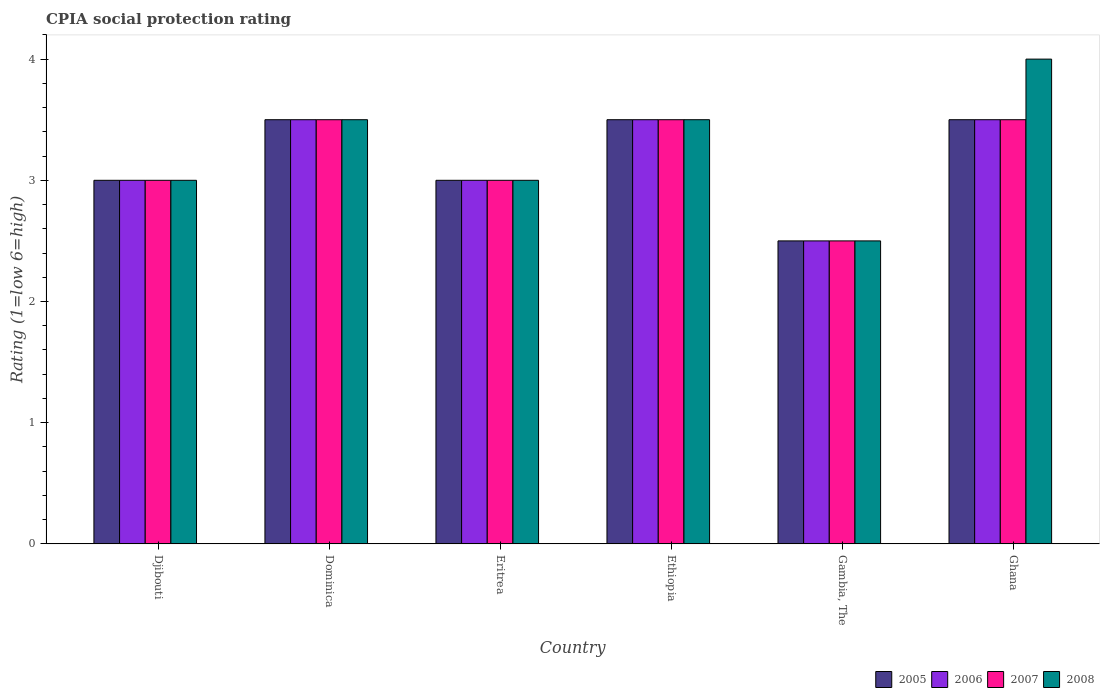How many different coloured bars are there?
Your response must be concise. 4. Are the number of bars per tick equal to the number of legend labels?
Offer a terse response. Yes. What is the label of the 3rd group of bars from the left?
Keep it short and to the point. Eritrea. In how many cases, is the number of bars for a given country not equal to the number of legend labels?
Your answer should be very brief. 0. What is the CPIA rating in 2008 in Eritrea?
Provide a succinct answer. 3. Across all countries, what is the maximum CPIA rating in 2007?
Your answer should be very brief. 3.5. Across all countries, what is the minimum CPIA rating in 2006?
Your answer should be very brief. 2.5. In which country was the CPIA rating in 2008 maximum?
Your answer should be very brief. Ghana. In which country was the CPIA rating in 2006 minimum?
Provide a short and direct response. Gambia, The. What is the total CPIA rating in 2007 in the graph?
Ensure brevity in your answer.  19. What is the difference between the CPIA rating in 2006 in Eritrea and that in Ghana?
Offer a terse response. -0.5. What is the difference between the CPIA rating in 2007 in Eritrea and the CPIA rating in 2005 in Ethiopia?
Ensure brevity in your answer.  -0.5. What is the average CPIA rating in 2006 per country?
Give a very brief answer. 3.17. What is the difference between the CPIA rating of/in 2008 and CPIA rating of/in 2007 in Gambia, The?
Your answer should be compact. 0. In how many countries, is the CPIA rating in 2007 greater than 1.2?
Make the answer very short. 6. What is the ratio of the CPIA rating in 2005 in Ethiopia to that in Gambia, The?
Your answer should be very brief. 1.4. In how many countries, is the CPIA rating in 2008 greater than the average CPIA rating in 2008 taken over all countries?
Your answer should be compact. 3. What does the 2nd bar from the right in Gambia, The represents?
Keep it short and to the point. 2007. Is it the case that in every country, the sum of the CPIA rating in 2006 and CPIA rating in 2007 is greater than the CPIA rating in 2005?
Your answer should be compact. Yes. Are all the bars in the graph horizontal?
Provide a succinct answer. No. How many countries are there in the graph?
Make the answer very short. 6. What is the difference between two consecutive major ticks on the Y-axis?
Your answer should be very brief. 1. Are the values on the major ticks of Y-axis written in scientific E-notation?
Keep it short and to the point. No. Does the graph contain any zero values?
Keep it short and to the point. No. Does the graph contain grids?
Make the answer very short. No. What is the title of the graph?
Make the answer very short. CPIA social protection rating. What is the label or title of the X-axis?
Your answer should be compact. Country. What is the Rating (1=low 6=high) in 2005 in Djibouti?
Offer a terse response. 3. What is the Rating (1=low 6=high) in 2006 in Djibouti?
Your answer should be very brief. 3. What is the Rating (1=low 6=high) in 2007 in Dominica?
Offer a terse response. 3.5. What is the Rating (1=low 6=high) in 2008 in Dominica?
Your answer should be compact. 3.5. What is the Rating (1=low 6=high) of 2005 in Eritrea?
Provide a succinct answer. 3. What is the Rating (1=low 6=high) of 2008 in Eritrea?
Give a very brief answer. 3. What is the Rating (1=low 6=high) of 2006 in Ethiopia?
Offer a very short reply. 3.5. What is the Rating (1=low 6=high) of 2006 in Gambia, The?
Your answer should be compact. 2.5. What is the Rating (1=low 6=high) in 2005 in Ghana?
Your answer should be very brief. 3.5. What is the Rating (1=low 6=high) in 2006 in Ghana?
Offer a very short reply. 3.5. What is the Rating (1=low 6=high) of 2007 in Ghana?
Ensure brevity in your answer.  3.5. Across all countries, what is the maximum Rating (1=low 6=high) in 2005?
Give a very brief answer. 3.5. Across all countries, what is the maximum Rating (1=low 6=high) of 2008?
Your answer should be compact. 4. Across all countries, what is the minimum Rating (1=low 6=high) of 2008?
Offer a very short reply. 2.5. What is the total Rating (1=low 6=high) in 2005 in the graph?
Offer a very short reply. 19. What is the total Rating (1=low 6=high) of 2008 in the graph?
Make the answer very short. 19.5. What is the difference between the Rating (1=low 6=high) in 2006 in Djibouti and that in Dominica?
Offer a very short reply. -0.5. What is the difference between the Rating (1=low 6=high) of 2007 in Djibouti and that in Dominica?
Offer a very short reply. -0.5. What is the difference between the Rating (1=low 6=high) of 2008 in Djibouti and that in Dominica?
Offer a very short reply. -0.5. What is the difference between the Rating (1=low 6=high) in 2006 in Djibouti and that in Eritrea?
Provide a short and direct response. 0. What is the difference between the Rating (1=low 6=high) of 2008 in Djibouti and that in Eritrea?
Offer a very short reply. 0. What is the difference between the Rating (1=low 6=high) in 2005 in Djibouti and that in Ethiopia?
Make the answer very short. -0.5. What is the difference between the Rating (1=low 6=high) of 2006 in Djibouti and that in Ethiopia?
Offer a very short reply. -0.5. What is the difference between the Rating (1=low 6=high) in 2005 in Djibouti and that in Gambia, The?
Your response must be concise. 0.5. What is the difference between the Rating (1=low 6=high) of 2006 in Djibouti and that in Gambia, The?
Your response must be concise. 0.5. What is the difference between the Rating (1=low 6=high) in 2008 in Djibouti and that in Gambia, The?
Ensure brevity in your answer.  0.5. What is the difference between the Rating (1=low 6=high) of 2005 in Djibouti and that in Ghana?
Your answer should be very brief. -0.5. What is the difference between the Rating (1=low 6=high) of 2008 in Djibouti and that in Ghana?
Offer a terse response. -1. What is the difference between the Rating (1=low 6=high) of 2006 in Dominica and that in Eritrea?
Offer a very short reply. 0.5. What is the difference between the Rating (1=low 6=high) in 2008 in Dominica and that in Eritrea?
Ensure brevity in your answer.  0.5. What is the difference between the Rating (1=low 6=high) of 2005 in Dominica and that in Ethiopia?
Provide a succinct answer. 0. What is the difference between the Rating (1=low 6=high) of 2007 in Dominica and that in Ethiopia?
Keep it short and to the point. 0. What is the difference between the Rating (1=low 6=high) in 2008 in Dominica and that in Ethiopia?
Offer a terse response. 0. What is the difference between the Rating (1=low 6=high) of 2005 in Dominica and that in Gambia, The?
Your answer should be very brief. 1. What is the difference between the Rating (1=low 6=high) in 2007 in Dominica and that in Gambia, The?
Offer a very short reply. 1. What is the difference between the Rating (1=low 6=high) in 2008 in Dominica and that in Gambia, The?
Make the answer very short. 1. What is the difference between the Rating (1=low 6=high) in 2006 in Dominica and that in Ghana?
Make the answer very short. 0. What is the difference between the Rating (1=low 6=high) in 2007 in Eritrea and that in Ethiopia?
Offer a terse response. -0.5. What is the difference between the Rating (1=low 6=high) in 2005 in Eritrea and that in Gambia, The?
Your answer should be very brief. 0.5. What is the difference between the Rating (1=low 6=high) of 2006 in Eritrea and that in Gambia, The?
Offer a very short reply. 0.5. What is the difference between the Rating (1=low 6=high) of 2008 in Eritrea and that in Gambia, The?
Your answer should be compact. 0.5. What is the difference between the Rating (1=low 6=high) in 2005 in Eritrea and that in Ghana?
Ensure brevity in your answer.  -0.5. What is the difference between the Rating (1=low 6=high) in 2008 in Eritrea and that in Ghana?
Your answer should be very brief. -1. What is the difference between the Rating (1=low 6=high) of 2006 in Ethiopia and that in Gambia, The?
Offer a terse response. 1. What is the difference between the Rating (1=low 6=high) of 2008 in Ethiopia and that in Gambia, The?
Offer a terse response. 1. What is the difference between the Rating (1=low 6=high) of 2008 in Ethiopia and that in Ghana?
Offer a terse response. -0.5. What is the difference between the Rating (1=low 6=high) in 2005 in Gambia, The and that in Ghana?
Provide a short and direct response. -1. What is the difference between the Rating (1=low 6=high) in 2006 in Gambia, The and that in Ghana?
Your response must be concise. -1. What is the difference between the Rating (1=low 6=high) in 2007 in Gambia, The and that in Ghana?
Ensure brevity in your answer.  -1. What is the difference between the Rating (1=low 6=high) in 2005 in Djibouti and the Rating (1=low 6=high) in 2006 in Dominica?
Keep it short and to the point. -0.5. What is the difference between the Rating (1=low 6=high) of 2005 in Djibouti and the Rating (1=low 6=high) of 2008 in Dominica?
Give a very brief answer. -0.5. What is the difference between the Rating (1=low 6=high) in 2007 in Djibouti and the Rating (1=low 6=high) in 2008 in Dominica?
Your answer should be compact. -0.5. What is the difference between the Rating (1=low 6=high) in 2006 in Djibouti and the Rating (1=low 6=high) in 2008 in Eritrea?
Your answer should be very brief. 0. What is the difference between the Rating (1=low 6=high) in 2005 in Djibouti and the Rating (1=low 6=high) in 2006 in Ethiopia?
Offer a very short reply. -0.5. What is the difference between the Rating (1=low 6=high) of 2005 in Djibouti and the Rating (1=low 6=high) of 2007 in Ethiopia?
Make the answer very short. -0.5. What is the difference between the Rating (1=low 6=high) in 2006 in Djibouti and the Rating (1=low 6=high) in 2008 in Ethiopia?
Your answer should be very brief. -0.5. What is the difference between the Rating (1=low 6=high) in 2006 in Djibouti and the Rating (1=low 6=high) in 2007 in Gambia, The?
Make the answer very short. 0.5. What is the difference between the Rating (1=low 6=high) of 2007 in Djibouti and the Rating (1=low 6=high) of 2008 in Gambia, The?
Ensure brevity in your answer.  0.5. What is the difference between the Rating (1=low 6=high) of 2005 in Djibouti and the Rating (1=low 6=high) of 2007 in Ghana?
Ensure brevity in your answer.  -0.5. What is the difference between the Rating (1=low 6=high) in 2006 in Djibouti and the Rating (1=low 6=high) in 2008 in Ghana?
Provide a succinct answer. -1. What is the difference between the Rating (1=low 6=high) of 2005 in Dominica and the Rating (1=low 6=high) of 2006 in Eritrea?
Your answer should be compact. 0.5. What is the difference between the Rating (1=low 6=high) in 2007 in Dominica and the Rating (1=low 6=high) in 2008 in Eritrea?
Your answer should be very brief. 0.5. What is the difference between the Rating (1=low 6=high) in 2006 in Dominica and the Rating (1=low 6=high) in 2007 in Gambia, The?
Offer a very short reply. 1. What is the difference between the Rating (1=low 6=high) of 2006 in Dominica and the Rating (1=low 6=high) of 2008 in Gambia, The?
Your answer should be very brief. 1. What is the difference between the Rating (1=low 6=high) of 2007 in Dominica and the Rating (1=low 6=high) of 2008 in Gambia, The?
Keep it short and to the point. 1. What is the difference between the Rating (1=low 6=high) of 2005 in Dominica and the Rating (1=low 6=high) of 2006 in Ghana?
Offer a terse response. 0. What is the difference between the Rating (1=low 6=high) in 2005 in Dominica and the Rating (1=low 6=high) in 2007 in Ghana?
Offer a very short reply. 0. What is the difference between the Rating (1=low 6=high) of 2005 in Dominica and the Rating (1=low 6=high) of 2008 in Ghana?
Provide a short and direct response. -0.5. What is the difference between the Rating (1=low 6=high) of 2006 in Dominica and the Rating (1=low 6=high) of 2007 in Ghana?
Your answer should be very brief. 0. What is the difference between the Rating (1=low 6=high) in 2005 in Eritrea and the Rating (1=low 6=high) in 2008 in Ethiopia?
Give a very brief answer. -0.5. What is the difference between the Rating (1=low 6=high) in 2005 in Eritrea and the Rating (1=low 6=high) in 2007 in Gambia, The?
Your response must be concise. 0.5. What is the difference between the Rating (1=low 6=high) in 2005 in Eritrea and the Rating (1=low 6=high) in 2008 in Gambia, The?
Ensure brevity in your answer.  0.5. What is the difference between the Rating (1=low 6=high) in 2006 in Eritrea and the Rating (1=low 6=high) in 2008 in Gambia, The?
Offer a terse response. 0.5. What is the difference between the Rating (1=low 6=high) in 2007 in Eritrea and the Rating (1=low 6=high) in 2008 in Gambia, The?
Ensure brevity in your answer.  0.5. What is the difference between the Rating (1=low 6=high) of 2006 in Eritrea and the Rating (1=low 6=high) of 2007 in Ghana?
Your answer should be very brief. -0.5. What is the difference between the Rating (1=low 6=high) in 2006 in Eritrea and the Rating (1=low 6=high) in 2008 in Ghana?
Offer a very short reply. -1. What is the difference between the Rating (1=low 6=high) in 2005 in Ethiopia and the Rating (1=low 6=high) in 2006 in Gambia, The?
Your answer should be very brief. 1. What is the difference between the Rating (1=low 6=high) of 2005 in Ethiopia and the Rating (1=low 6=high) of 2007 in Gambia, The?
Provide a succinct answer. 1. What is the difference between the Rating (1=low 6=high) in 2005 in Ethiopia and the Rating (1=low 6=high) in 2008 in Gambia, The?
Keep it short and to the point. 1. What is the difference between the Rating (1=low 6=high) of 2006 in Ethiopia and the Rating (1=low 6=high) of 2007 in Gambia, The?
Offer a very short reply. 1. What is the difference between the Rating (1=low 6=high) in 2006 in Ethiopia and the Rating (1=low 6=high) in 2008 in Gambia, The?
Ensure brevity in your answer.  1. What is the difference between the Rating (1=low 6=high) in 2007 in Ethiopia and the Rating (1=low 6=high) in 2008 in Gambia, The?
Give a very brief answer. 1. What is the difference between the Rating (1=low 6=high) of 2005 in Ethiopia and the Rating (1=low 6=high) of 2006 in Ghana?
Give a very brief answer. 0. What is the difference between the Rating (1=low 6=high) of 2006 in Ethiopia and the Rating (1=low 6=high) of 2008 in Ghana?
Make the answer very short. -0.5. What is the difference between the Rating (1=low 6=high) of 2007 in Ethiopia and the Rating (1=low 6=high) of 2008 in Ghana?
Your response must be concise. -0.5. What is the difference between the Rating (1=low 6=high) of 2005 in Gambia, The and the Rating (1=low 6=high) of 2007 in Ghana?
Provide a short and direct response. -1. What is the difference between the Rating (1=low 6=high) in 2005 in Gambia, The and the Rating (1=low 6=high) in 2008 in Ghana?
Keep it short and to the point. -1.5. What is the difference between the Rating (1=low 6=high) of 2006 in Gambia, The and the Rating (1=low 6=high) of 2007 in Ghana?
Keep it short and to the point. -1. What is the difference between the Rating (1=low 6=high) in 2006 in Gambia, The and the Rating (1=low 6=high) in 2008 in Ghana?
Provide a succinct answer. -1.5. What is the average Rating (1=low 6=high) in 2005 per country?
Offer a very short reply. 3.17. What is the average Rating (1=low 6=high) of 2006 per country?
Offer a terse response. 3.17. What is the average Rating (1=low 6=high) of 2007 per country?
Provide a succinct answer. 3.17. What is the average Rating (1=low 6=high) in 2008 per country?
Make the answer very short. 3.25. What is the difference between the Rating (1=low 6=high) in 2005 and Rating (1=low 6=high) in 2007 in Djibouti?
Make the answer very short. 0. What is the difference between the Rating (1=low 6=high) in 2006 and Rating (1=low 6=high) in 2008 in Djibouti?
Ensure brevity in your answer.  0. What is the difference between the Rating (1=low 6=high) of 2007 and Rating (1=low 6=high) of 2008 in Djibouti?
Offer a very short reply. 0. What is the difference between the Rating (1=low 6=high) in 2005 and Rating (1=low 6=high) in 2007 in Dominica?
Provide a short and direct response. 0. What is the difference between the Rating (1=low 6=high) in 2005 and Rating (1=low 6=high) in 2008 in Dominica?
Keep it short and to the point. 0. What is the difference between the Rating (1=low 6=high) of 2006 and Rating (1=low 6=high) of 2007 in Dominica?
Provide a short and direct response. 0. What is the difference between the Rating (1=low 6=high) in 2006 and Rating (1=low 6=high) in 2008 in Dominica?
Your response must be concise. 0. What is the difference between the Rating (1=low 6=high) of 2005 and Rating (1=low 6=high) of 2007 in Eritrea?
Provide a short and direct response. 0. What is the difference between the Rating (1=low 6=high) of 2005 and Rating (1=low 6=high) of 2008 in Eritrea?
Your answer should be very brief. 0. What is the difference between the Rating (1=low 6=high) of 2006 and Rating (1=low 6=high) of 2007 in Eritrea?
Give a very brief answer. 0. What is the difference between the Rating (1=low 6=high) in 2005 and Rating (1=low 6=high) in 2007 in Ethiopia?
Give a very brief answer. 0. What is the difference between the Rating (1=low 6=high) in 2007 and Rating (1=low 6=high) in 2008 in Ethiopia?
Your response must be concise. 0. What is the difference between the Rating (1=low 6=high) in 2005 and Rating (1=low 6=high) in 2007 in Gambia, The?
Your answer should be compact. 0. What is the difference between the Rating (1=low 6=high) of 2005 and Rating (1=low 6=high) of 2008 in Gambia, The?
Your response must be concise. 0. What is the difference between the Rating (1=low 6=high) of 2006 and Rating (1=low 6=high) of 2007 in Gambia, The?
Give a very brief answer. 0. What is the difference between the Rating (1=low 6=high) of 2006 and Rating (1=low 6=high) of 2008 in Gambia, The?
Make the answer very short. 0. What is the difference between the Rating (1=low 6=high) in 2007 and Rating (1=low 6=high) in 2008 in Gambia, The?
Make the answer very short. 0. What is the difference between the Rating (1=low 6=high) in 2005 and Rating (1=low 6=high) in 2007 in Ghana?
Provide a short and direct response. 0. What is the difference between the Rating (1=low 6=high) of 2005 and Rating (1=low 6=high) of 2008 in Ghana?
Ensure brevity in your answer.  -0.5. What is the difference between the Rating (1=low 6=high) in 2007 and Rating (1=low 6=high) in 2008 in Ghana?
Your response must be concise. -0.5. What is the ratio of the Rating (1=low 6=high) of 2005 in Djibouti to that in Eritrea?
Provide a short and direct response. 1. What is the ratio of the Rating (1=low 6=high) of 2006 in Djibouti to that in Eritrea?
Your answer should be compact. 1. What is the ratio of the Rating (1=low 6=high) of 2008 in Djibouti to that in Eritrea?
Make the answer very short. 1. What is the ratio of the Rating (1=low 6=high) of 2005 in Djibouti to that in Ethiopia?
Your answer should be compact. 0.86. What is the ratio of the Rating (1=low 6=high) in 2007 in Djibouti to that in Ethiopia?
Your answer should be compact. 0.86. What is the ratio of the Rating (1=low 6=high) in 2008 in Djibouti to that in Ethiopia?
Keep it short and to the point. 0.86. What is the ratio of the Rating (1=low 6=high) of 2005 in Djibouti to that in Gambia, The?
Ensure brevity in your answer.  1.2. What is the ratio of the Rating (1=low 6=high) in 2006 in Djibouti to that in Gambia, The?
Provide a short and direct response. 1.2. What is the ratio of the Rating (1=low 6=high) of 2008 in Djibouti to that in Gambia, The?
Provide a short and direct response. 1.2. What is the ratio of the Rating (1=low 6=high) of 2008 in Dominica to that in Ethiopia?
Your response must be concise. 1. What is the ratio of the Rating (1=low 6=high) of 2007 in Dominica to that in Gambia, The?
Keep it short and to the point. 1.4. What is the ratio of the Rating (1=low 6=high) in 2008 in Dominica to that in Gambia, The?
Your answer should be compact. 1.4. What is the ratio of the Rating (1=low 6=high) in 2005 in Dominica to that in Ghana?
Offer a terse response. 1. What is the ratio of the Rating (1=low 6=high) of 2006 in Dominica to that in Ghana?
Ensure brevity in your answer.  1. What is the ratio of the Rating (1=low 6=high) in 2008 in Dominica to that in Ghana?
Offer a very short reply. 0.88. What is the ratio of the Rating (1=low 6=high) in 2006 in Eritrea to that in Ethiopia?
Make the answer very short. 0.86. What is the ratio of the Rating (1=low 6=high) in 2007 in Eritrea to that in Ethiopia?
Offer a terse response. 0.86. What is the ratio of the Rating (1=low 6=high) of 2008 in Eritrea to that in Ethiopia?
Your answer should be compact. 0.86. What is the ratio of the Rating (1=low 6=high) in 2005 in Eritrea to that in Gambia, The?
Offer a very short reply. 1.2. What is the ratio of the Rating (1=low 6=high) in 2006 in Eritrea to that in Gambia, The?
Offer a very short reply. 1.2. What is the ratio of the Rating (1=low 6=high) of 2005 in Eritrea to that in Ghana?
Make the answer very short. 0.86. What is the ratio of the Rating (1=low 6=high) of 2006 in Eritrea to that in Ghana?
Your response must be concise. 0.86. What is the ratio of the Rating (1=low 6=high) in 2007 in Eritrea to that in Ghana?
Offer a terse response. 0.86. What is the ratio of the Rating (1=low 6=high) in 2005 in Ethiopia to that in Gambia, The?
Make the answer very short. 1.4. What is the ratio of the Rating (1=low 6=high) in 2006 in Ethiopia to that in Gambia, The?
Your answer should be compact. 1.4. What is the ratio of the Rating (1=low 6=high) in 2007 in Ethiopia to that in Gambia, The?
Your answer should be very brief. 1.4. What is the ratio of the Rating (1=low 6=high) in 2005 in Ethiopia to that in Ghana?
Make the answer very short. 1. What is the ratio of the Rating (1=low 6=high) of 2007 in Ethiopia to that in Ghana?
Keep it short and to the point. 1. What is the ratio of the Rating (1=low 6=high) in 2008 in Ethiopia to that in Ghana?
Keep it short and to the point. 0.88. What is the ratio of the Rating (1=low 6=high) in 2006 in Gambia, The to that in Ghana?
Keep it short and to the point. 0.71. What is the ratio of the Rating (1=low 6=high) of 2007 in Gambia, The to that in Ghana?
Give a very brief answer. 0.71. What is the difference between the highest and the second highest Rating (1=low 6=high) in 2005?
Provide a succinct answer. 0. What is the difference between the highest and the second highest Rating (1=low 6=high) in 2006?
Your answer should be compact. 0. What is the difference between the highest and the second highest Rating (1=low 6=high) in 2008?
Your response must be concise. 0.5. What is the difference between the highest and the lowest Rating (1=low 6=high) of 2005?
Your answer should be very brief. 1. What is the difference between the highest and the lowest Rating (1=low 6=high) in 2006?
Offer a terse response. 1. 